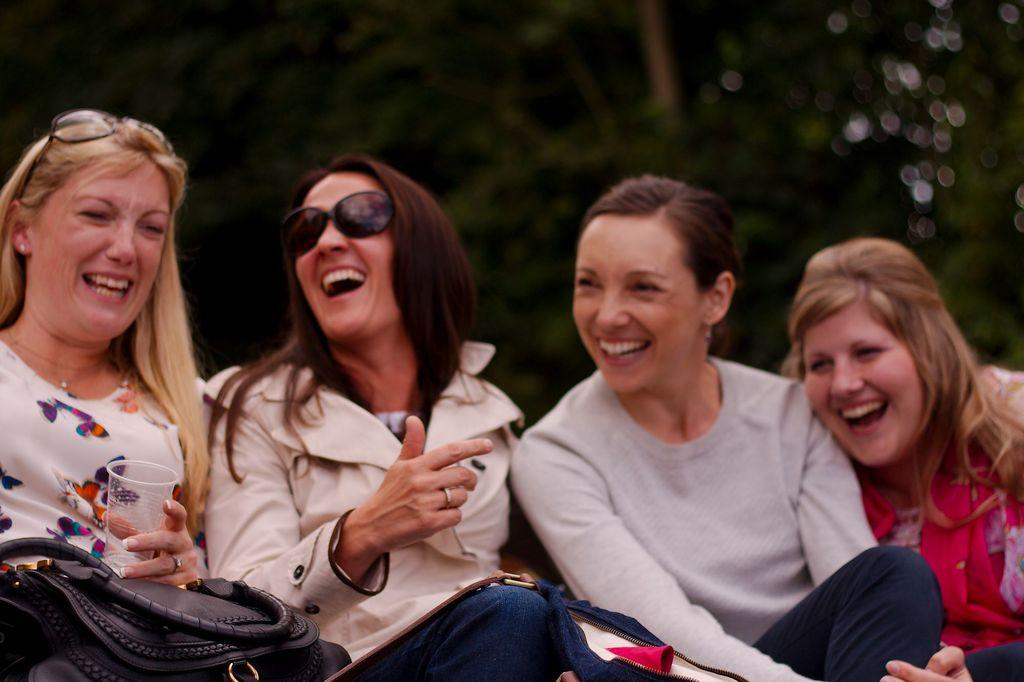How many women are present in the image? There are four women sitting in the image. What are the women doing in the image? The women are laughing. What is the woman to the left holding in her hand? The woman to the left is holding a glass in her hand. What can be seen in the background of the image? There are trees visible in the background of the image. How would you describe the background of the image? The background of the image is blurry. How many girls are sitting on the rail in the image? There are no girls or rails present in the image. 